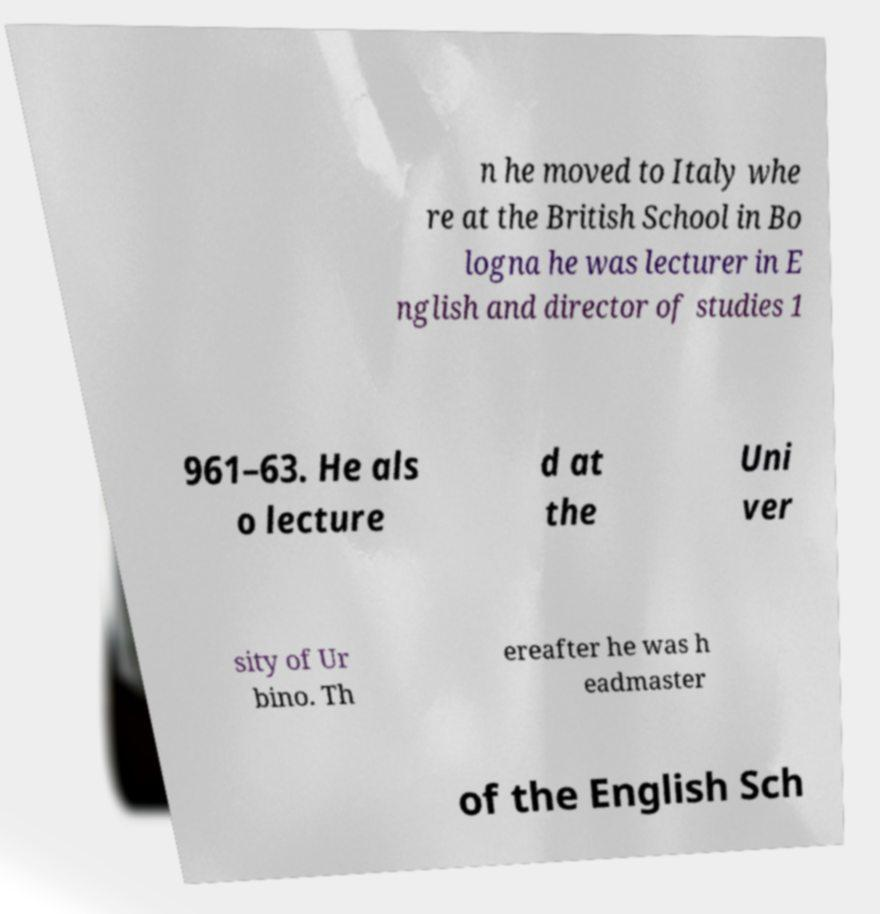Please read and relay the text visible in this image. What does it say? n he moved to Italy whe re at the British School in Bo logna he was lecturer in E nglish and director of studies 1 961–63. He als o lecture d at the Uni ver sity of Ur bino. Th ereafter he was h eadmaster of the English Sch 